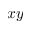<formula> <loc_0><loc_0><loc_500><loc_500>x y</formula> 